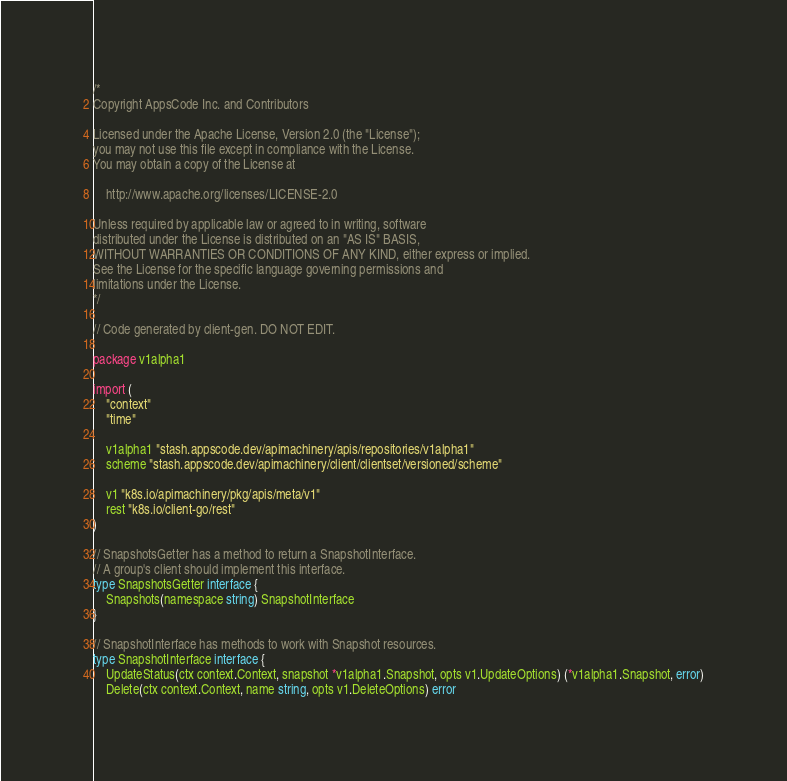Convert code to text. <code><loc_0><loc_0><loc_500><loc_500><_Go_>/*
Copyright AppsCode Inc. and Contributors

Licensed under the Apache License, Version 2.0 (the "License");
you may not use this file except in compliance with the License.
You may obtain a copy of the License at

    http://www.apache.org/licenses/LICENSE-2.0

Unless required by applicable law or agreed to in writing, software
distributed under the License is distributed on an "AS IS" BASIS,
WITHOUT WARRANTIES OR CONDITIONS OF ANY KIND, either express or implied.
See the License for the specific language governing permissions and
limitations under the License.
*/

// Code generated by client-gen. DO NOT EDIT.

package v1alpha1

import (
	"context"
	"time"

	v1alpha1 "stash.appscode.dev/apimachinery/apis/repositories/v1alpha1"
	scheme "stash.appscode.dev/apimachinery/client/clientset/versioned/scheme"

	v1 "k8s.io/apimachinery/pkg/apis/meta/v1"
	rest "k8s.io/client-go/rest"
)

// SnapshotsGetter has a method to return a SnapshotInterface.
// A group's client should implement this interface.
type SnapshotsGetter interface {
	Snapshots(namespace string) SnapshotInterface
}

// SnapshotInterface has methods to work with Snapshot resources.
type SnapshotInterface interface {
	UpdateStatus(ctx context.Context, snapshot *v1alpha1.Snapshot, opts v1.UpdateOptions) (*v1alpha1.Snapshot, error)
	Delete(ctx context.Context, name string, opts v1.DeleteOptions) error</code> 